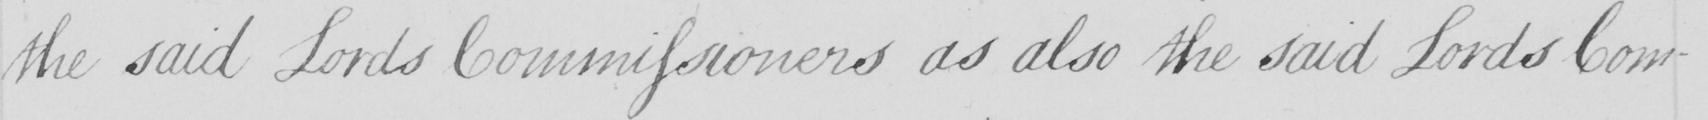What does this handwritten line say? the said Lords Commissioners as also the said Lords Com- 